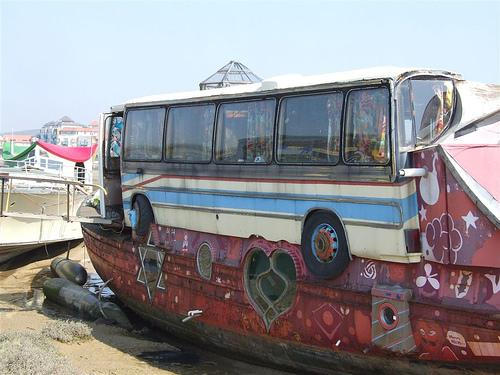What do people most likely do in the structure? sleep 